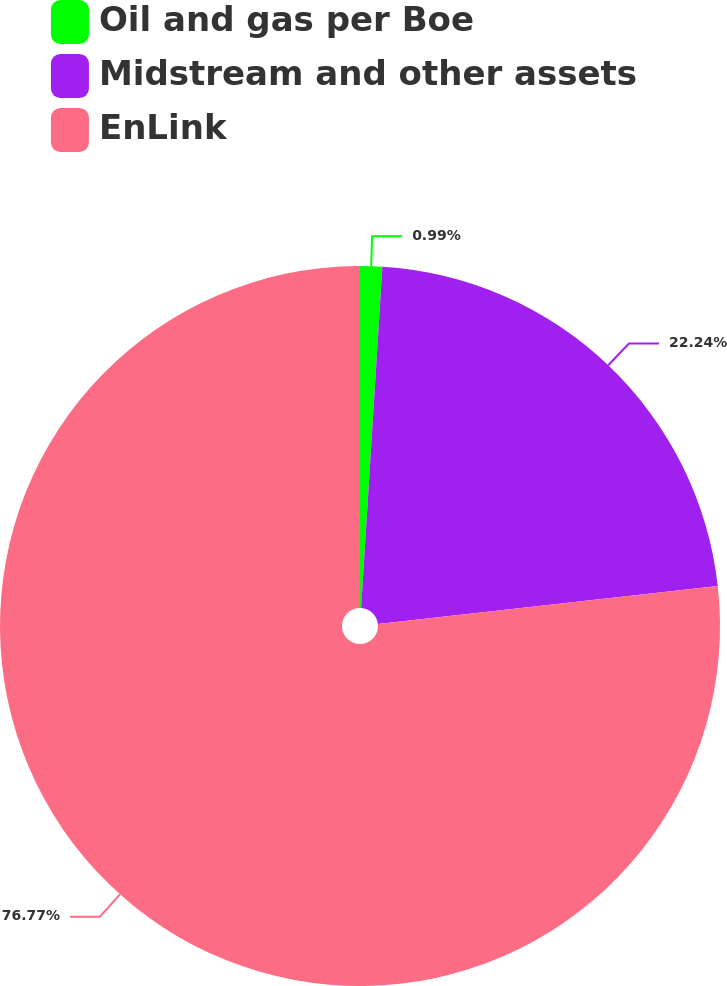Convert chart. <chart><loc_0><loc_0><loc_500><loc_500><pie_chart><fcel>Oil and gas per Boe<fcel>Midstream and other assets<fcel>EnLink<nl><fcel>0.99%<fcel>22.24%<fcel>76.77%<nl></chart> 